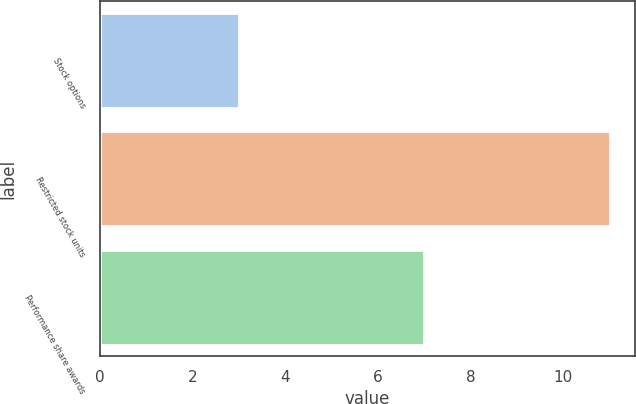Convert chart. <chart><loc_0><loc_0><loc_500><loc_500><bar_chart><fcel>Stock options<fcel>Restricted stock units<fcel>Performance share awards<nl><fcel>3<fcel>11<fcel>7<nl></chart> 